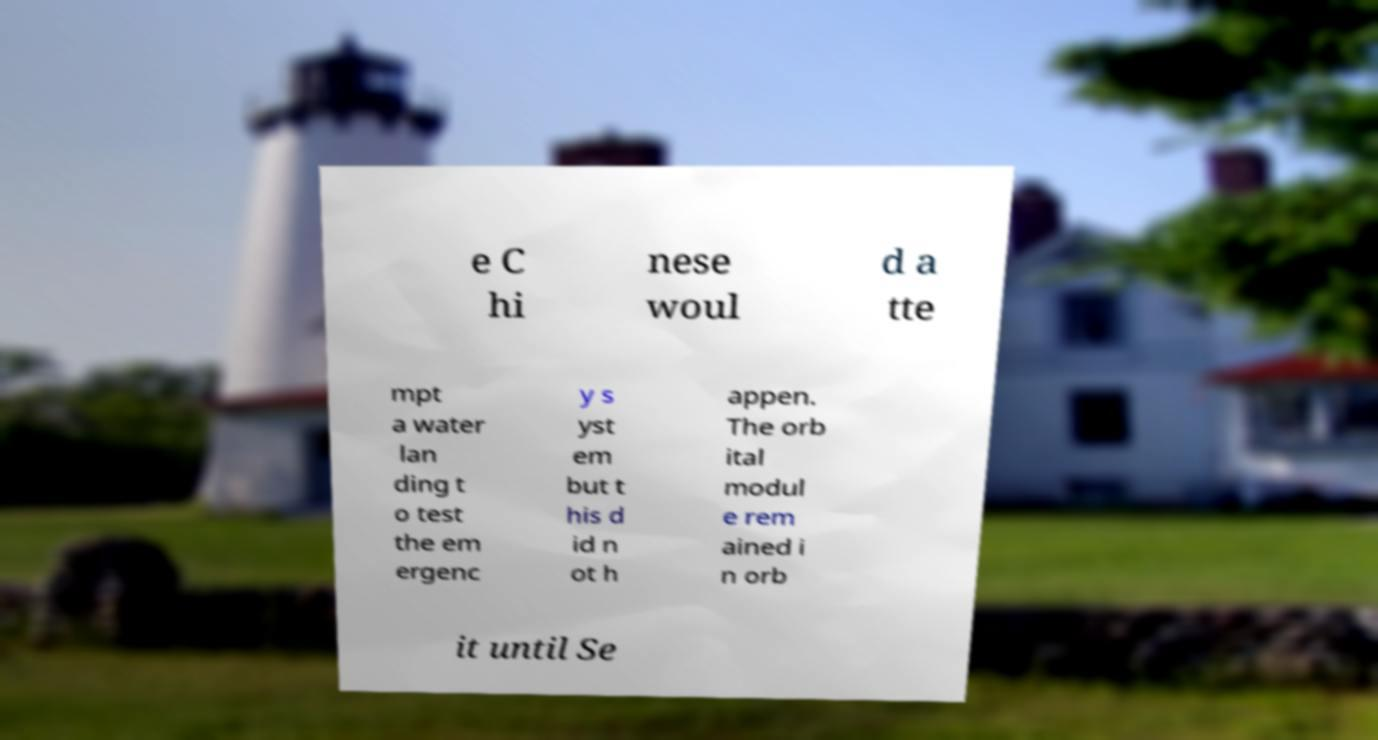I need the written content from this picture converted into text. Can you do that? e C hi nese woul d a tte mpt a water lan ding t o test the em ergenc y s yst em but t his d id n ot h appen. The orb ital modul e rem ained i n orb it until Se 